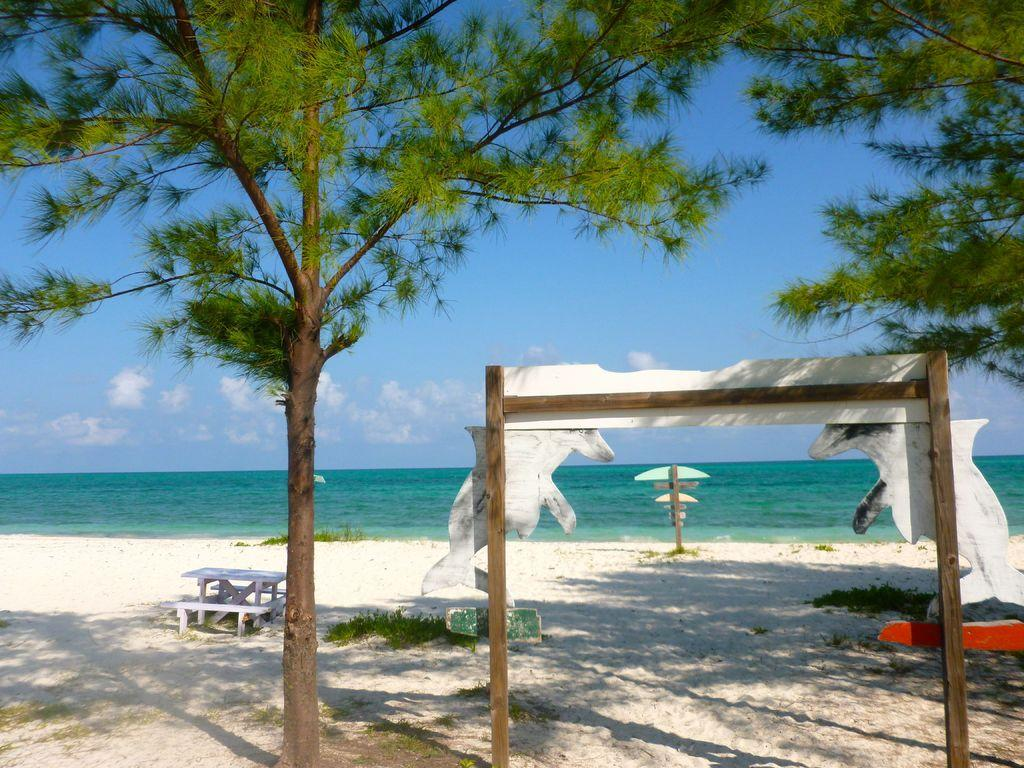What type of location is depicted in the image? The image contains a beach. What natural elements can be seen on the beach? There are trees and plants on the beach. What man-made object is present on the beach? There is a bench on the beach. What can be seen in the background of the image? There is water and clouds visible in the background of the image. What song is being sung by the people on the beach in the image? There are no people singing in the image, nor is there any indication of a song being sung. 